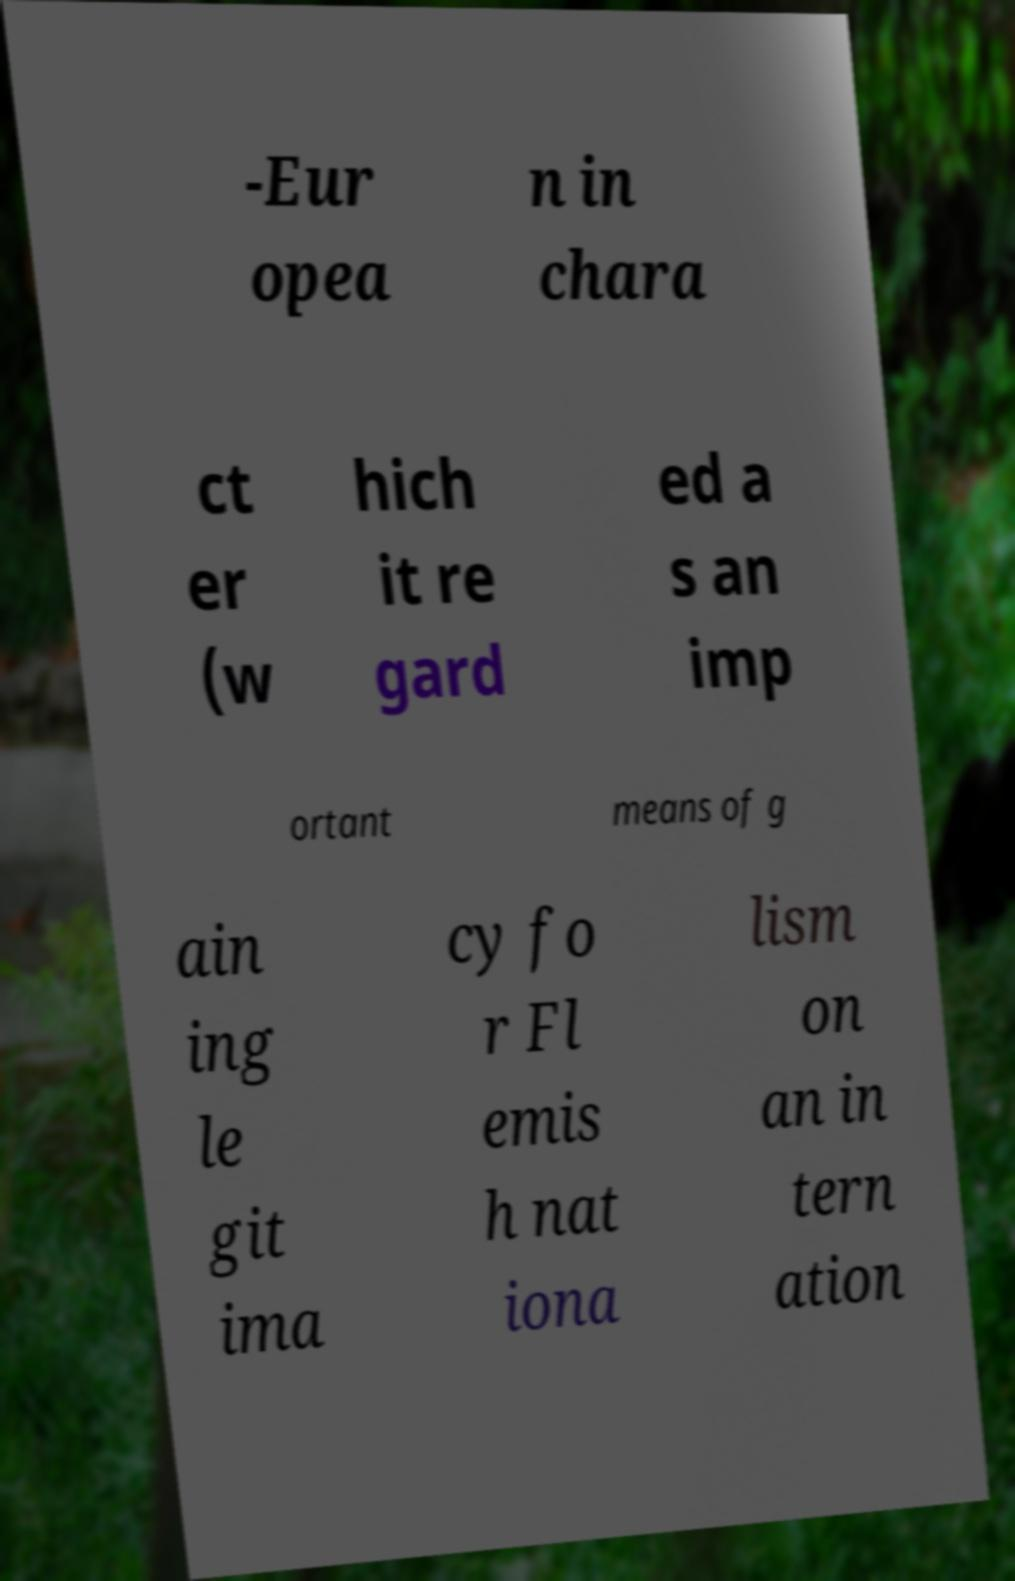Can you accurately transcribe the text from the provided image for me? -Eur opea n in chara ct er (w hich it re gard ed a s an imp ortant means of g ain ing le git ima cy fo r Fl emis h nat iona lism on an in tern ation 